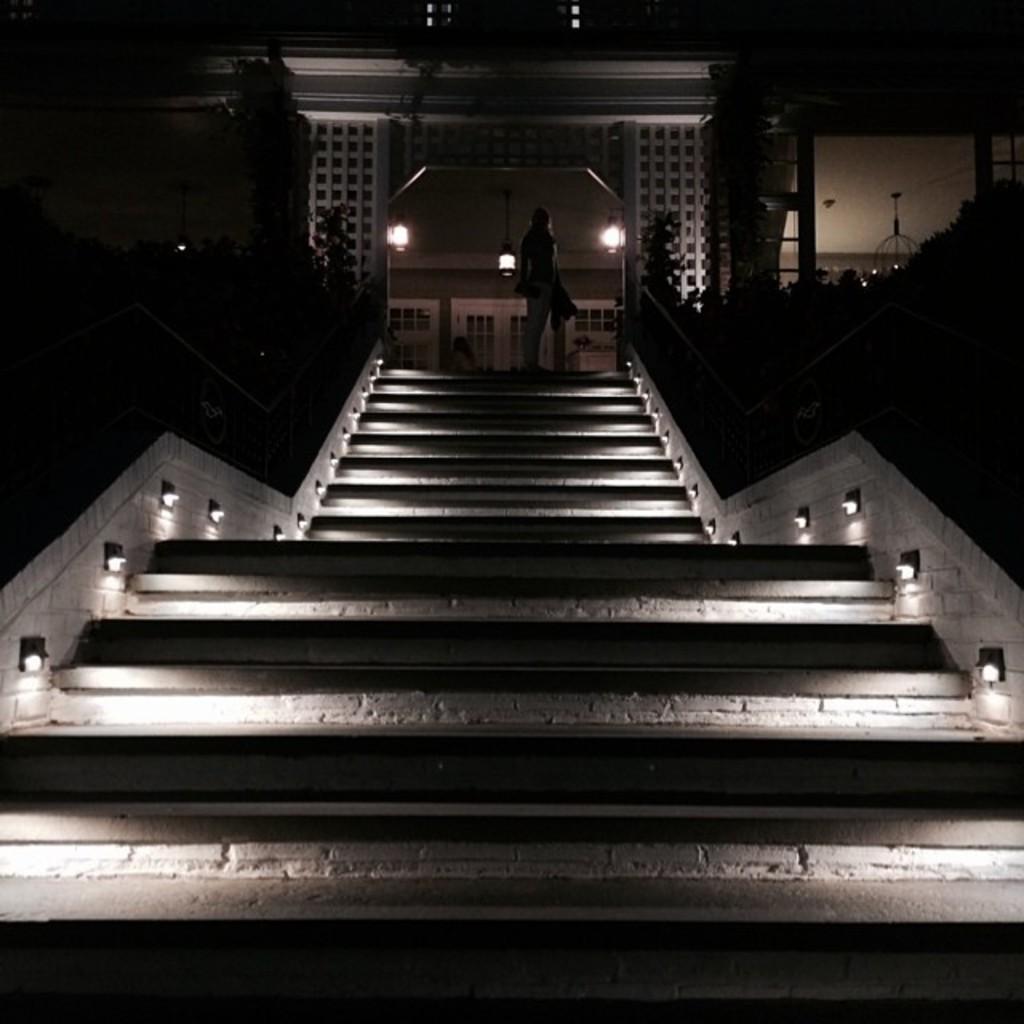Could you give a brief overview of what you see in this image? In this image there is a building at top of this image and there are stairs in the bottom of this image. and there is one person standing at top of this image. and there are some lights arranged at left side of this image and right side of this image. There are three lights at top of this image. 